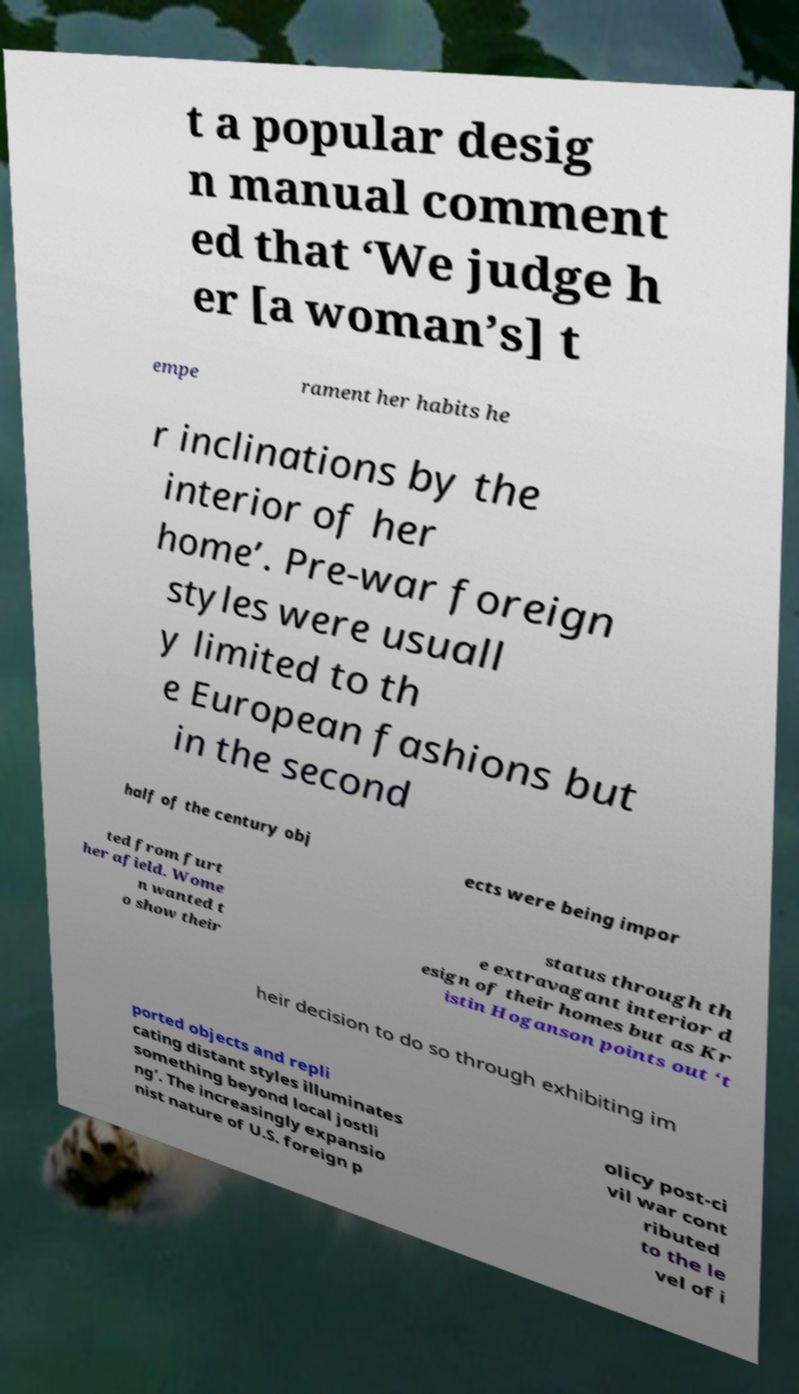Could you extract and type out the text from this image? t a popular desig n manual comment ed that ‘We judge h er [a woman’s] t empe rament her habits he r inclinations by the interior of her home’. Pre-war foreign styles were usuall y limited to th e European fashions but in the second half of the century obj ects were being impor ted from furt her afield. Wome n wanted t o show their status through th e extravagant interior d esign of their homes but as Kr istin Hoganson points out ‘t heir decision to do so through exhibiting im ported objects and repli cating distant styles illuminates something beyond local jostli ng’. The increasingly expansio nist nature of U.S. foreign p olicy post-ci vil war cont ributed to the le vel of i 